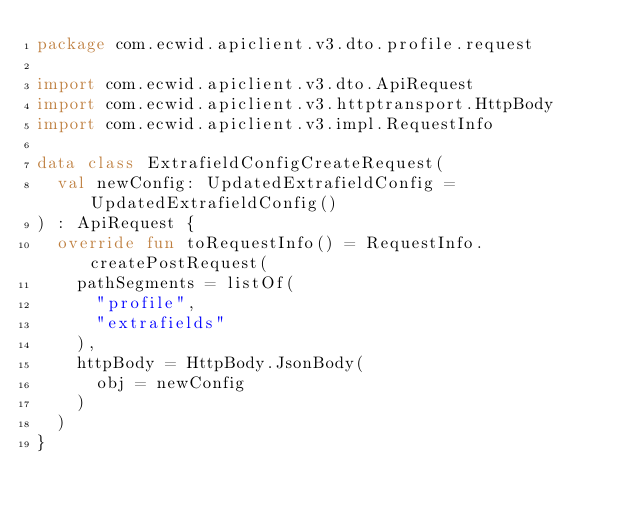<code> <loc_0><loc_0><loc_500><loc_500><_Kotlin_>package com.ecwid.apiclient.v3.dto.profile.request

import com.ecwid.apiclient.v3.dto.ApiRequest
import com.ecwid.apiclient.v3.httptransport.HttpBody
import com.ecwid.apiclient.v3.impl.RequestInfo

data class ExtrafieldConfigCreateRequest(
	val newConfig: UpdatedExtrafieldConfig = UpdatedExtrafieldConfig()
) : ApiRequest {
	override fun toRequestInfo() = RequestInfo.createPostRequest(
		pathSegments = listOf(
			"profile",
			"extrafields"
		),
		httpBody = HttpBody.JsonBody(
			obj = newConfig
		)
	)
}
</code> 